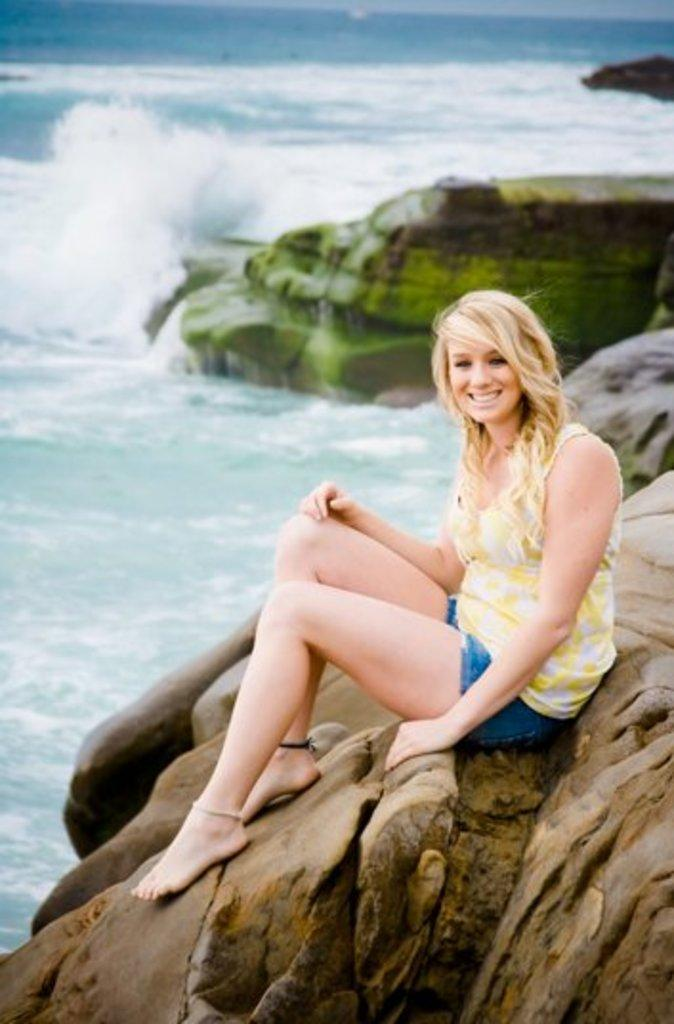Who is present in the image? There is a woman in the image. What is the woman wearing? The woman is wearing a dress with yellow, white, and blue colors. Where is the woman sitting? The woman is sitting on a rock. What can be seen in the image besides the woman? There is water visible in the image, as well as rocks. What is visible in the background of the image? The sky is visible in the background of the image. What flavor of mouthwash is the woman using in the image? There is no mouthwash or indication of mouthwash use in the image. 